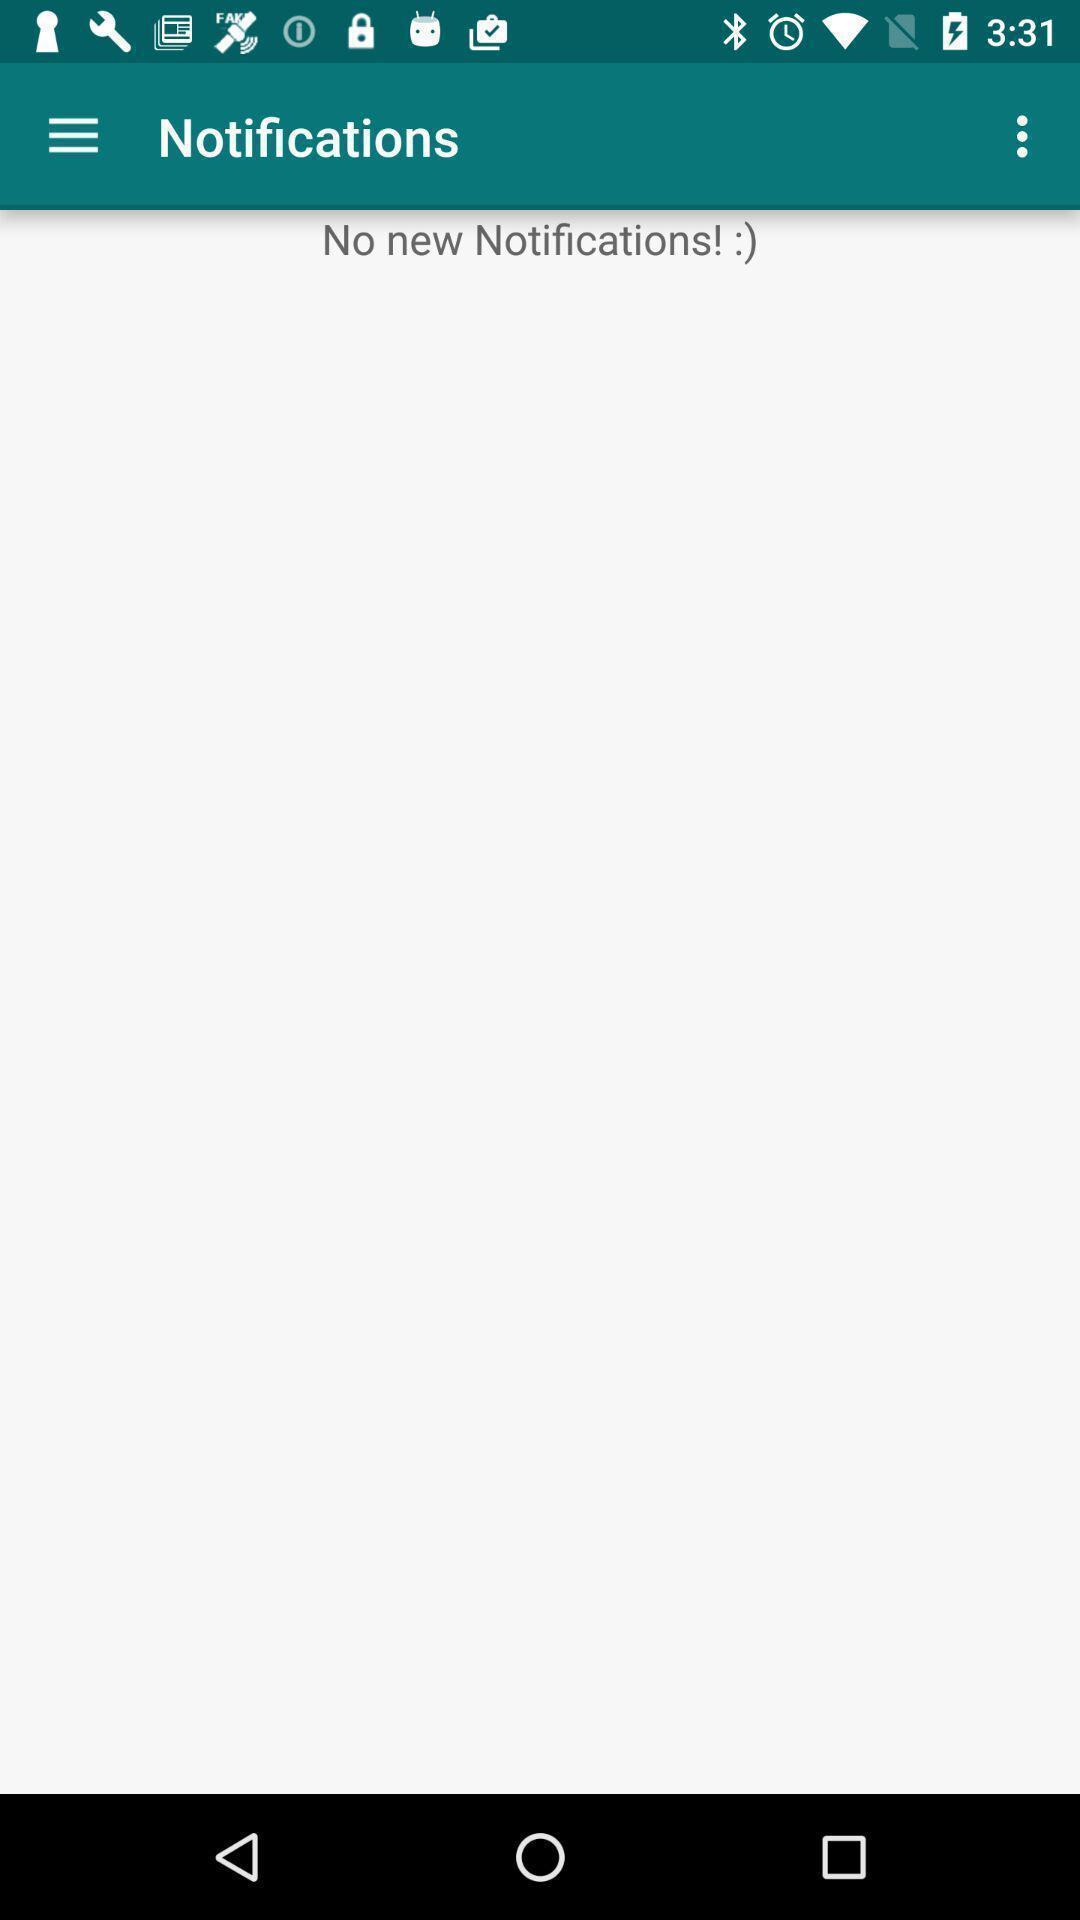What is the overall content of this screenshot? Page shows the empty notification log. 